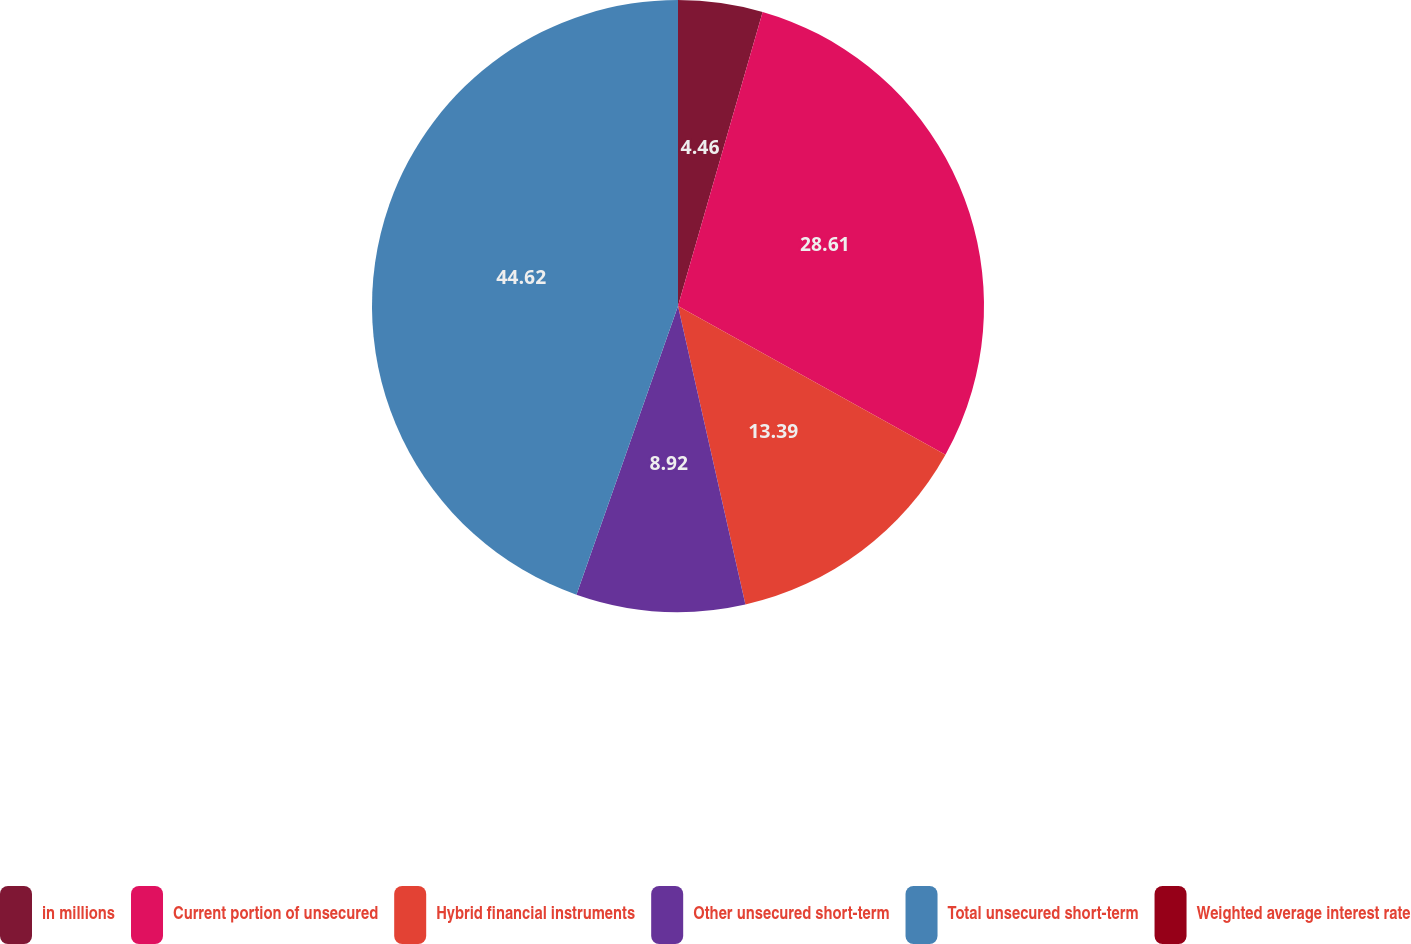<chart> <loc_0><loc_0><loc_500><loc_500><pie_chart><fcel>in millions<fcel>Current portion of unsecured<fcel>Hybrid financial instruments<fcel>Other unsecured short-term<fcel>Total unsecured short-term<fcel>Weighted average interest rate<nl><fcel>4.46%<fcel>28.61%<fcel>13.39%<fcel>8.92%<fcel>44.61%<fcel>0.0%<nl></chart> 